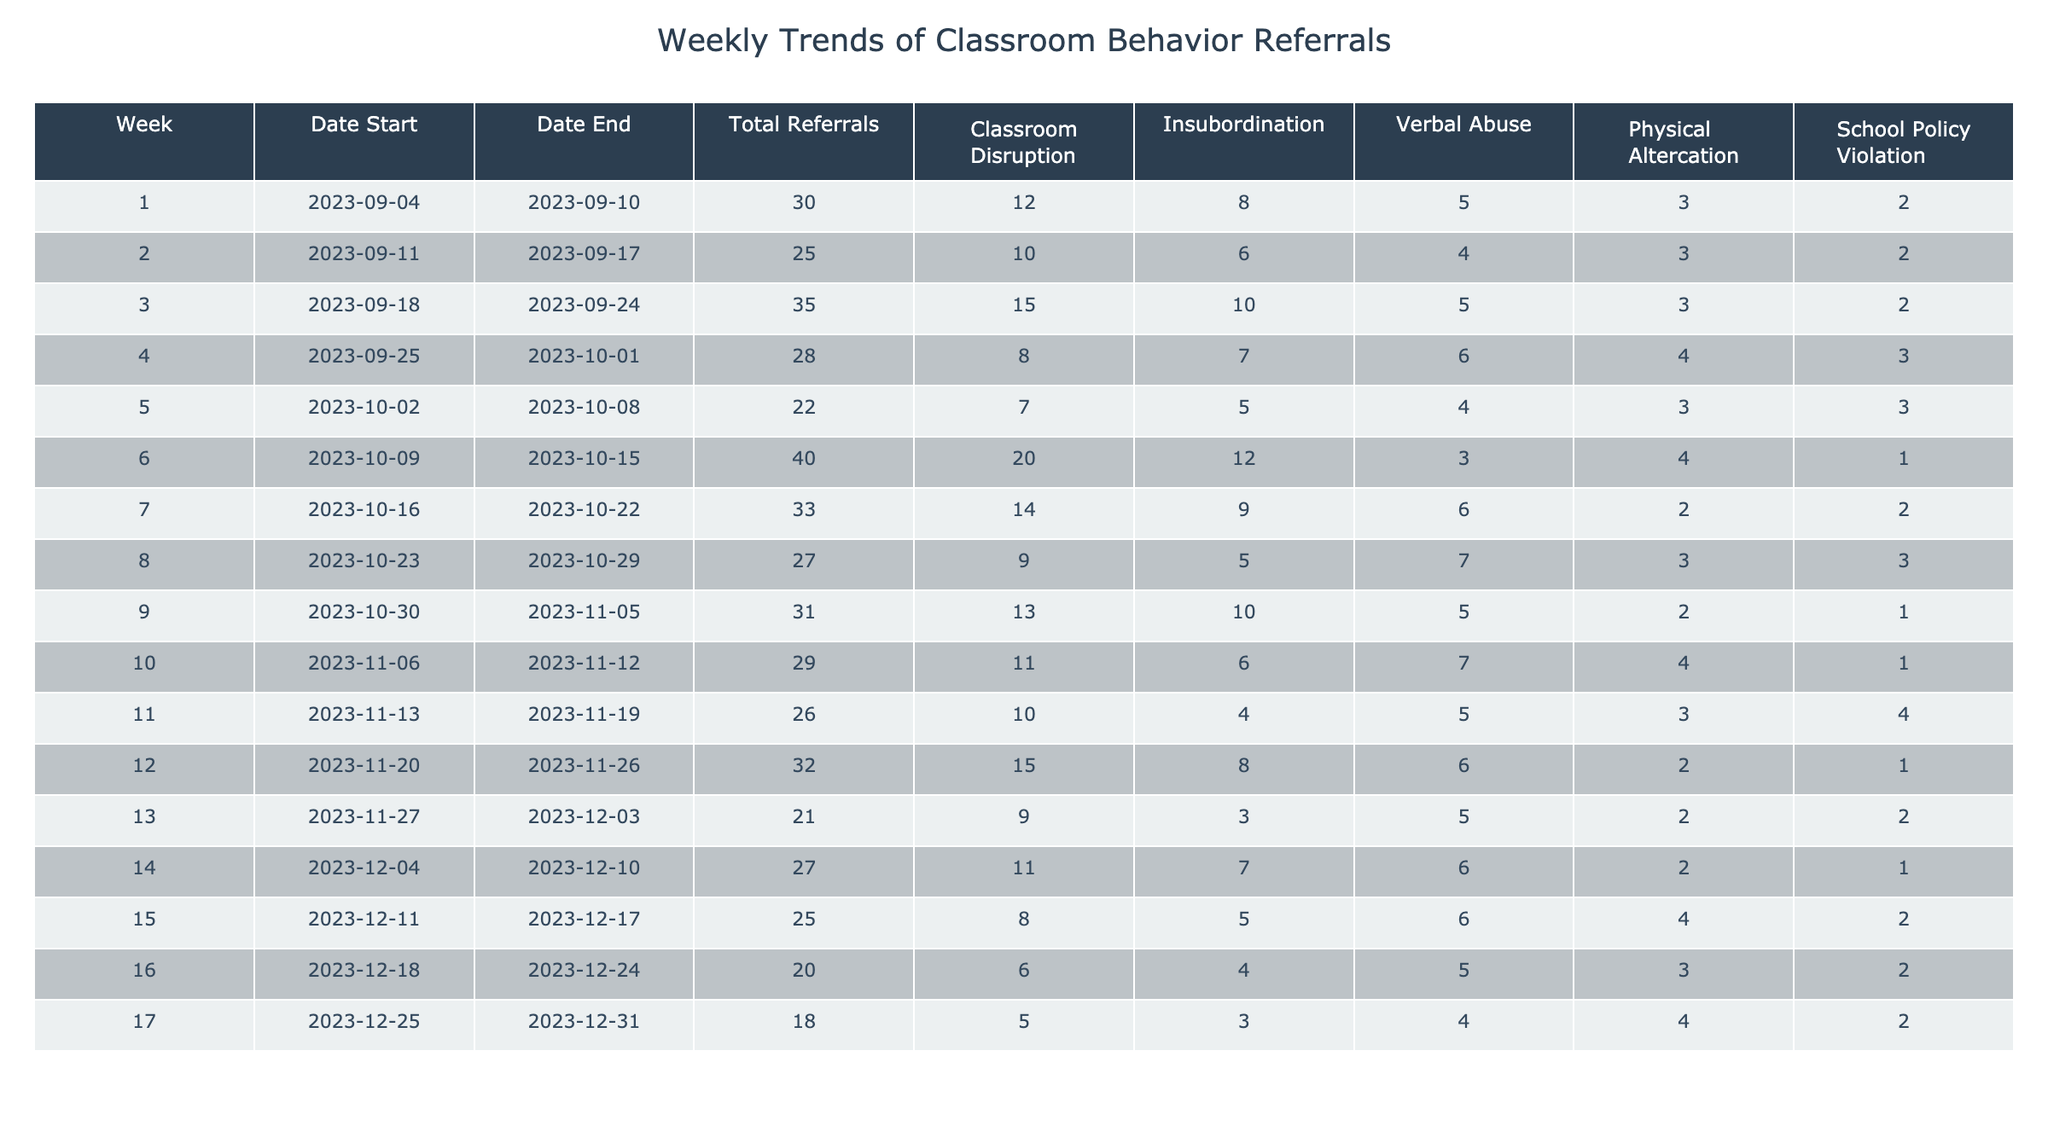What was the total number of referrals in Week 6? By checking the table, the total referrals for Week 6 (2023-10-09 to 2023-10-15) is listed directly in the "Total Referrals" column, which shows a value of 40.
Answer: 40 Which week had the highest classroom disruption referrals? In the "Classroom Disruption" column, Week 6 has the highest value at 20, compared to other weeks by scanning down the column.
Answer: Week 6 What is the average number of physical altercations per week? To find the average, add the values of physical altercations across all weeks (3 + 3 + 4 + 2 + 3 + 4 + 2 + 3 + 4 + 3 + 2 + 2 + 1 + 4 + 2 + 3 + 4 = 45) and divide by the number of weeks (17). So, 45/17 ≈ 2.65.
Answer: 2.65 Did the number of school policy violations increase in the last three weeks compared to the previous three weeks? Review the last three weeks (18, 1, 2) and the previous three weeks (3, 2, 4). The last three weeks had a total of 1+1+2 = 4 violations, while the previous three weeks had a total of 3+3+2 = 8 violations. Thus, the number of violations decreased.
Answer: No Which week had more total referrals: Week 4 or Week 5? Referencing the "Total Referrals" column, Week 4 has 28 referrals and Week 5 has 22 referrals. Comparing these values shows that Week 4 had more referrals than Week 5.
Answer: Week 4 What was the total number of referrals for weeks 1 to 3 combined? To find the combined total for weeks 1 to 3, sum the total referrals: 30 (Week 1) + 25 (Week 2) + 35 (Week 3) = 90.
Answer: 90 Was there any week that had no verbal abuse referrals? Checking the "Verbal Abuse" column, Week 6 shows a value of 3, and all other weeks have values greater than 0. Therefore, there was no week with zero verbal abuse referrals.
Answer: No Which behavior category had the lowest total across all weeks? Add up each behavior category: Classroom Disruption (151), Insubordination (70), Verbal Abuse (61), Physical Altercation (38), School Policy Violation (29). The category with the lowest total is School Policy Violation with a total of 29.
Answer: School Policy Violation In which week did the number of insubordination referrals peak? Inspecting the "Insubordination" column, Week 6 has the maximum value of 12 referrals. By reviewing each week's count, it's clear that this is the highest recorded.
Answer: Week 6 